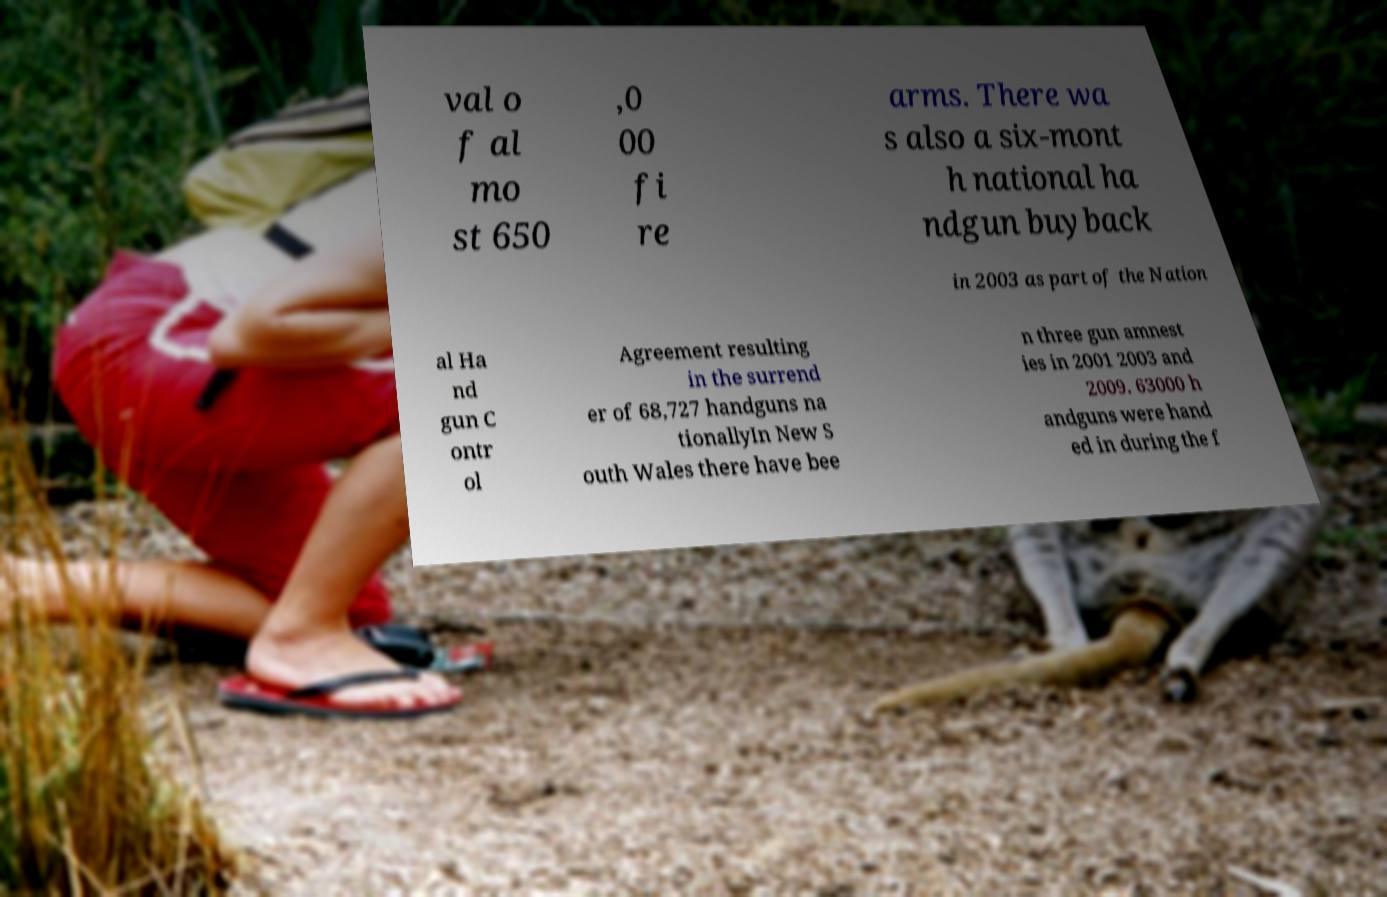Could you assist in decoding the text presented in this image and type it out clearly? val o f al mo st 650 ,0 00 fi re arms. There wa s also a six-mont h national ha ndgun buyback in 2003 as part of the Nation al Ha nd gun C ontr ol Agreement resulting in the surrend er of 68,727 handguns na tionallyIn New S outh Wales there have bee n three gun amnest ies in 2001 2003 and 2009. 63000 h andguns were hand ed in during the f 